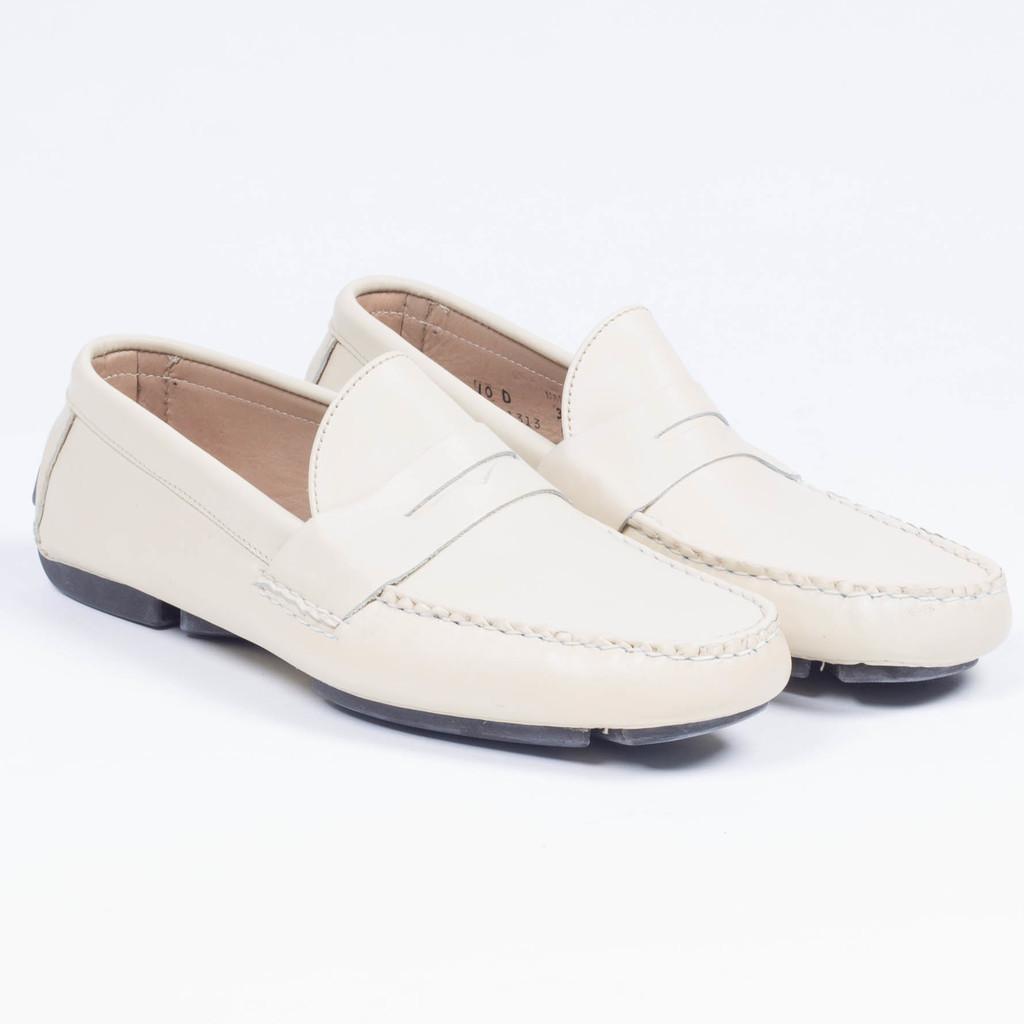Can you describe this image briefly? In this image we can see shoes and white background. 